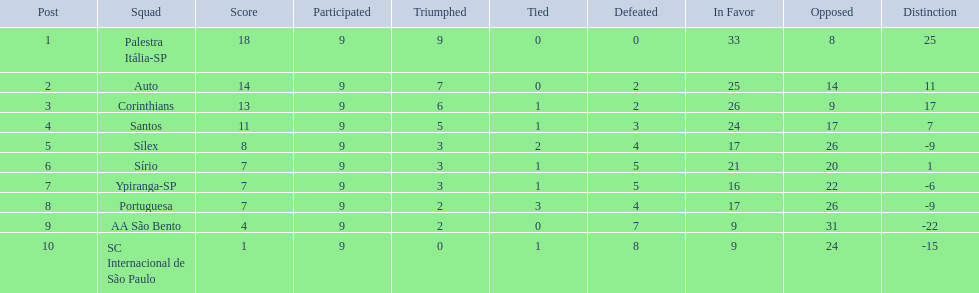In 1926 brazilian football, how many teams scored above 10 points in the season? 4. 